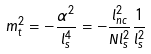Convert formula to latex. <formula><loc_0><loc_0><loc_500><loc_500>m _ { t } ^ { 2 } = - \frac { \alpha ^ { 2 } } { l _ { s } ^ { 4 } } = - \frac { l _ { n c } ^ { 2 } } { N l _ { s } ^ { 2 } } \frac { 1 } { l _ { s } ^ { 2 } }</formula> 